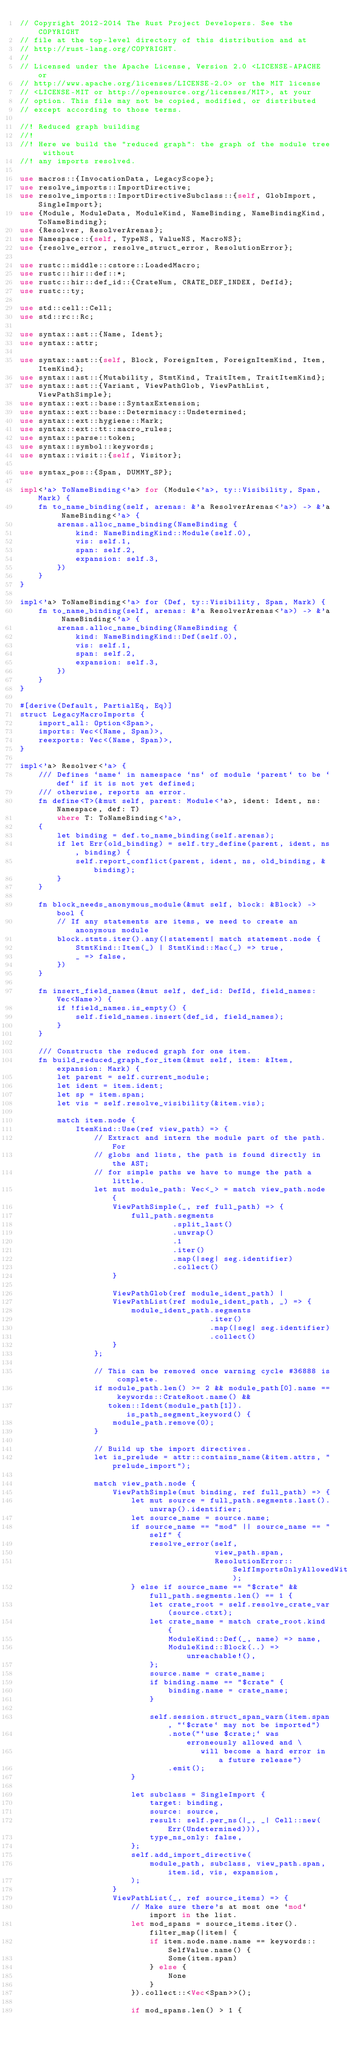<code> <loc_0><loc_0><loc_500><loc_500><_Rust_>// Copyright 2012-2014 The Rust Project Developers. See the COPYRIGHT
// file at the top-level directory of this distribution and at
// http://rust-lang.org/COPYRIGHT.
//
// Licensed under the Apache License, Version 2.0 <LICENSE-APACHE or
// http://www.apache.org/licenses/LICENSE-2.0> or the MIT license
// <LICENSE-MIT or http://opensource.org/licenses/MIT>, at your
// option. This file may not be copied, modified, or distributed
// except according to those terms.

//! Reduced graph building
//!
//! Here we build the "reduced graph": the graph of the module tree without
//! any imports resolved.

use macros::{InvocationData, LegacyScope};
use resolve_imports::ImportDirective;
use resolve_imports::ImportDirectiveSubclass::{self, GlobImport, SingleImport};
use {Module, ModuleData, ModuleKind, NameBinding, NameBindingKind, ToNameBinding};
use {Resolver, ResolverArenas};
use Namespace::{self, TypeNS, ValueNS, MacroNS};
use {resolve_error, resolve_struct_error, ResolutionError};

use rustc::middle::cstore::LoadedMacro;
use rustc::hir::def::*;
use rustc::hir::def_id::{CrateNum, CRATE_DEF_INDEX, DefId};
use rustc::ty;

use std::cell::Cell;
use std::rc::Rc;

use syntax::ast::{Name, Ident};
use syntax::attr;

use syntax::ast::{self, Block, ForeignItem, ForeignItemKind, Item, ItemKind};
use syntax::ast::{Mutability, StmtKind, TraitItem, TraitItemKind};
use syntax::ast::{Variant, ViewPathGlob, ViewPathList, ViewPathSimple};
use syntax::ext::base::SyntaxExtension;
use syntax::ext::base::Determinacy::Undetermined;
use syntax::ext::hygiene::Mark;
use syntax::ext::tt::macro_rules;
use syntax::parse::token;
use syntax::symbol::keywords;
use syntax::visit::{self, Visitor};

use syntax_pos::{Span, DUMMY_SP};

impl<'a> ToNameBinding<'a> for (Module<'a>, ty::Visibility, Span, Mark) {
    fn to_name_binding(self, arenas: &'a ResolverArenas<'a>) -> &'a NameBinding<'a> {
        arenas.alloc_name_binding(NameBinding {
            kind: NameBindingKind::Module(self.0),
            vis: self.1,
            span: self.2,
            expansion: self.3,
        })
    }
}

impl<'a> ToNameBinding<'a> for (Def, ty::Visibility, Span, Mark) {
    fn to_name_binding(self, arenas: &'a ResolverArenas<'a>) -> &'a NameBinding<'a> {
        arenas.alloc_name_binding(NameBinding {
            kind: NameBindingKind::Def(self.0),
            vis: self.1,
            span: self.2,
            expansion: self.3,
        })
    }
}

#[derive(Default, PartialEq, Eq)]
struct LegacyMacroImports {
    import_all: Option<Span>,
    imports: Vec<(Name, Span)>,
    reexports: Vec<(Name, Span)>,
}

impl<'a> Resolver<'a> {
    /// Defines `name` in namespace `ns` of module `parent` to be `def` if it is not yet defined;
    /// otherwise, reports an error.
    fn define<T>(&mut self, parent: Module<'a>, ident: Ident, ns: Namespace, def: T)
        where T: ToNameBinding<'a>,
    {
        let binding = def.to_name_binding(self.arenas);
        if let Err(old_binding) = self.try_define(parent, ident, ns, binding) {
            self.report_conflict(parent, ident, ns, old_binding, &binding);
        }
    }

    fn block_needs_anonymous_module(&mut self, block: &Block) -> bool {
        // If any statements are items, we need to create an anonymous module
        block.stmts.iter().any(|statement| match statement.node {
            StmtKind::Item(_) | StmtKind::Mac(_) => true,
            _ => false,
        })
    }

    fn insert_field_names(&mut self, def_id: DefId, field_names: Vec<Name>) {
        if !field_names.is_empty() {
            self.field_names.insert(def_id, field_names);
        }
    }

    /// Constructs the reduced graph for one item.
    fn build_reduced_graph_for_item(&mut self, item: &Item, expansion: Mark) {
        let parent = self.current_module;
        let ident = item.ident;
        let sp = item.span;
        let vis = self.resolve_visibility(&item.vis);

        match item.node {
            ItemKind::Use(ref view_path) => {
                // Extract and intern the module part of the path. For
                // globs and lists, the path is found directly in the AST;
                // for simple paths we have to munge the path a little.
                let mut module_path: Vec<_> = match view_path.node {
                    ViewPathSimple(_, ref full_path) => {
                        full_path.segments
                                 .split_last()
                                 .unwrap()
                                 .1
                                 .iter()
                                 .map(|seg| seg.identifier)
                                 .collect()
                    }

                    ViewPathGlob(ref module_ident_path) |
                    ViewPathList(ref module_ident_path, _) => {
                        module_ident_path.segments
                                         .iter()
                                         .map(|seg| seg.identifier)
                                         .collect()
                    }
                };

                // This can be removed once warning cycle #36888 is complete.
                if module_path.len() >= 2 && module_path[0].name == keywords::CrateRoot.name() &&
                   token::Ident(module_path[1]).is_path_segment_keyword() {
                    module_path.remove(0);
                }

                // Build up the import directives.
                let is_prelude = attr::contains_name(&item.attrs, "prelude_import");

                match view_path.node {
                    ViewPathSimple(mut binding, ref full_path) => {
                        let mut source = full_path.segments.last().unwrap().identifier;
                        let source_name = source.name;
                        if source_name == "mod" || source_name == "self" {
                            resolve_error(self,
                                          view_path.span,
                                          ResolutionError::SelfImportsOnlyAllowedWithin);
                        } else if source_name == "$crate" && full_path.segments.len() == 1 {
                            let crate_root = self.resolve_crate_var(source.ctxt);
                            let crate_name = match crate_root.kind {
                                ModuleKind::Def(_, name) => name,
                                ModuleKind::Block(..) => unreachable!(),
                            };
                            source.name = crate_name;
                            if binding.name == "$crate" {
                                binding.name = crate_name;
                            }

                            self.session.struct_span_warn(item.span, "`$crate` may not be imported")
                                .note("`use $crate;` was erroneously allowed and \
                                       will become a hard error in a future release")
                                .emit();
                        }

                        let subclass = SingleImport {
                            target: binding,
                            source: source,
                            result: self.per_ns(|_, _| Cell::new(Err(Undetermined))),
                            type_ns_only: false,
                        };
                        self.add_import_directive(
                            module_path, subclass, view_path.span, item.id, vis, expansion,
                        );
                    }
                    ViewPathList(_, ref source_items) => {
                        // Make sure there's at most one `mod` import in the list.
                        let mod_spans = source_items.iter().filter_map(|item| {
                            if item.node.name.name == keywords::SelfValue.name() {
                                Some(item.span)
                            } else {
                                None
                            }
                        }).collect::<Vec<Span>>();

                        if mod_spans.len() > 1 {</code> 